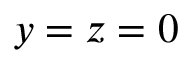<formula> <loc_0><loc_0><loc_500><loc_500>y = z = 0</formula> 